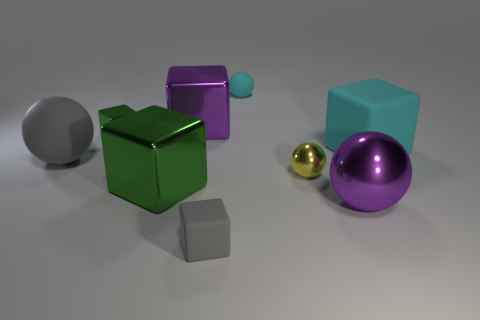Are there more big cyan matte objects than small cyan cylinders? Upon reviewing the image, it appears that there is only one large cyan matte object, which is a cube, and no small cyan cylinders present. Thus, the question of there being 'more' big cyan objects than small cyan cylinders is slightly misleading since there are no small cyan cylinders to compare with. However, it's clear that the single large cyan object exceeds in number compared to non-existent small cyan cylinders. 